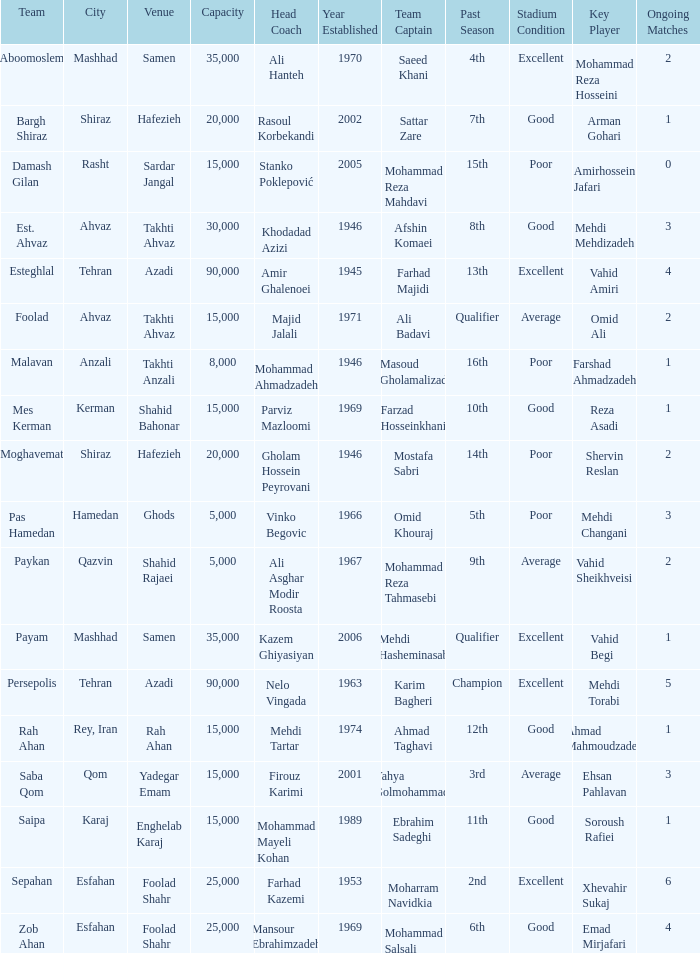What Venue has a Past Season of 2nd? Foolad Shahr. 